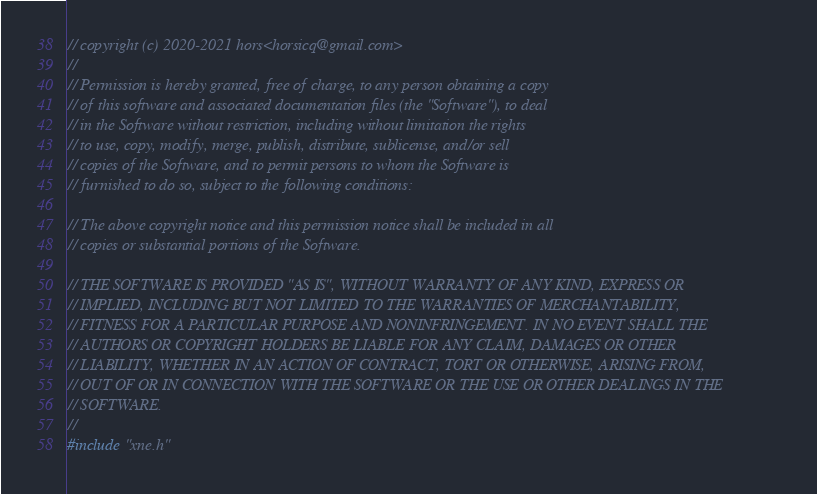Convert code to text. <code><loc_0><loc_0><loc_500><loc_500><_C++_>// copyright (c) 2020-2021 hors<horsicq@gmail.com>
//
// Permission is hereby granted, free of charge, to any person obtaining a copy
// of this software and associated documentation files (the "Software"), to deal
// in the Software without restriction, including without limitation the rights
// to use, copy, modify, merge, publish, distribute, sublicense, and/or sell
// copies of the Software, and to permit persons to whom the Software is
// furnished to do so, subject to the following conditions:

// The above copyright notice and this permission notice shall be included in all
// copies or substantial portions of the Software.

// THE SOFTWARE IS PROVIDED "AS IS", WITHOUT WARRANTY OF ANY KIND, EXPRESS OR
// IMPLIED, INCLUDING BUT NOT LIMITED TO THE WARRANTIES OF MERCHANTABILITY,
// FITNESS FOR A PARTICULAR PURPOSE AND NONINFRINGEMENT. IN NO EVENT SHALL THE
// AUTHORS OR COPYRIGHT HOLDERS BE LIABLE FOR ANY CLAIM, DAMAGES OR OTHER
// LIABILITY, WHETHER IN AN ACTION OF CONTRACT, TORT OR OTHERWISE, ARISING FROM,
// OUT OF OR IN CONNECTION WITH THE SOFTWARE OR THE USE OR OTHER DEALINGS IN THE
// SOFTWARE.
//
#include "xne.h"
</code> 